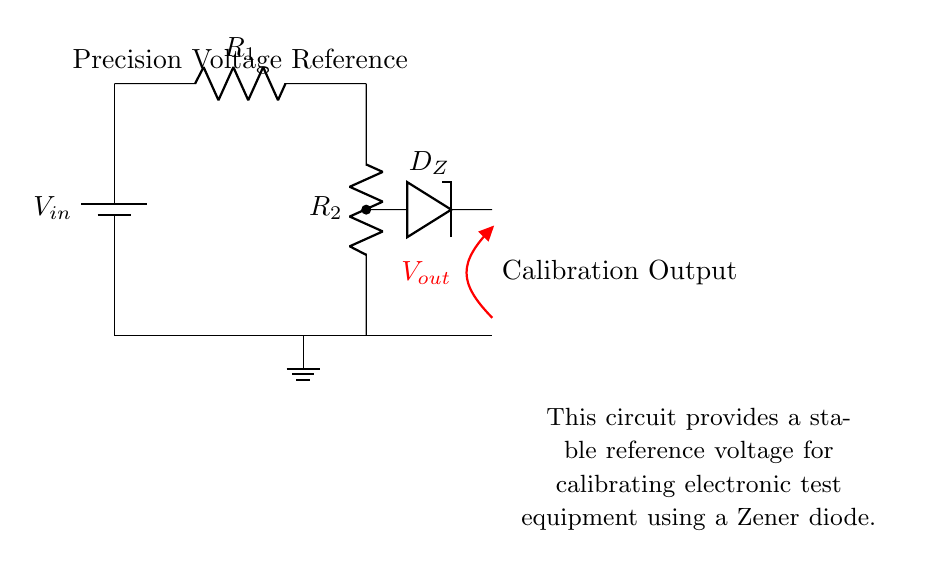What is the input voltage in the circuit? The input voltage, denoted as V_in, is connected to the top of the resistor R_1. Since there is no specific value provided in the diagram, we simply identify it as V_in.
Answer: V_in What component provides stable voltage output? The Zener diode, labeled as D_Z, is responsible for providing a stable voltage reference in the circuit, which is critical for calibration processes.
Answer: D_Z What is the function of the resistors R_1 and R_2? Resistors R_1 and R_2 are part of a voltage divider that helps in regulating the voltage output across the Zener diode, which contributes to obtaining a stable reference voltage.
Answer: Voltage divider What is the purpose of the ground connection in this circuit? The ground connection serves as a common return path for the current in the circuit and establishes a zero voltage reference point, which is essential for accurate measurements and operation.
Answer: Common return path How does the output voltage relate to the Zener diode? The output voltage, V_out, is taken from the Zener diode, which clamps the voltage at its breakdown voltage level, thus ensuring V_out remains stable despite variations in V_in or load conditions.
Answer: Stable reference voltage What type of circuit is this? This circuit is a precision voltage reference circuit leveraging a Zener diode for calibration purposes, suitable for electronic test equipment applications.
Answer: Precision voltage reference circuit 